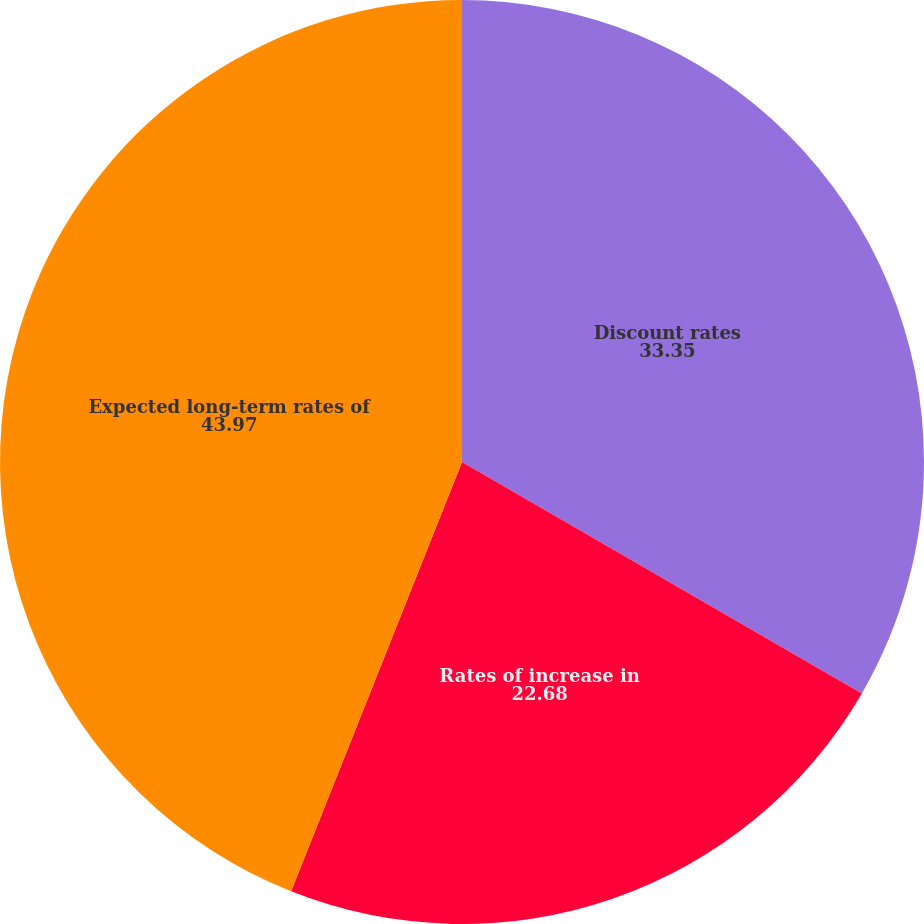Convert chart to OTSL. <chart><loc_0><loc_0><loc_500><loc_500><pie_chart><fcel>Discount rates<fcel>Rates of increase in<fcel>Expected long-term rates of<nl><fcel>33.35%<fcel>22.68%<fcel>43.97%<nl></chart> 